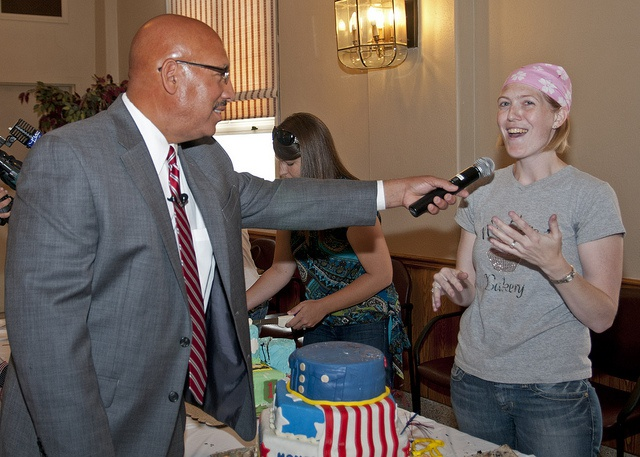Describe the objects in this image and their specific colors. I can see people in gray, black, and brown tones, people in gray and black tones, people in gray, black, brown, and maroon tones, bench in gray, black, maroon, and darkgray tones, and cake in gray, blue, and darkblue tones in this image. 